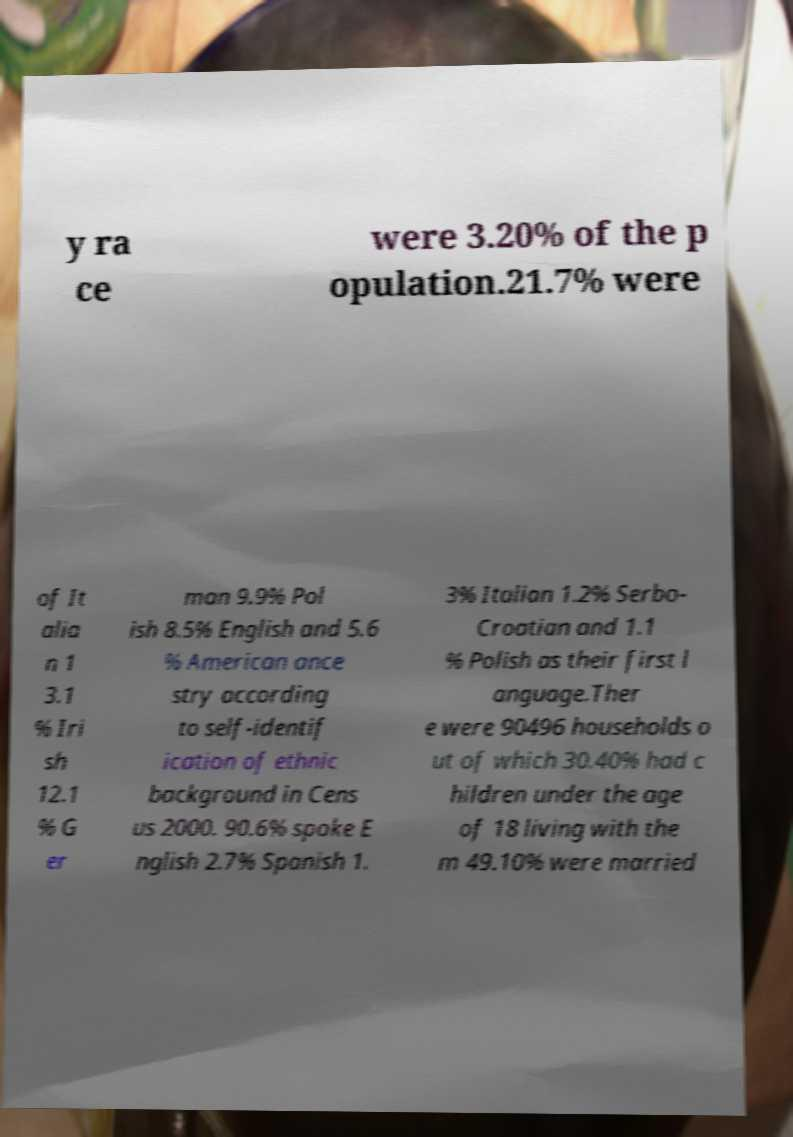Please read and relay the text visible in this image. What does it say? y ra ce were 3.20% of the p opulation.21.7% were of It alia n 1 3.1 % Iri sh 12.1 % G er man 9.9% Pol ish 8.5% English and 5.6 % American ance stry according to self-identif ication of ethnic background in Cens us 2000. 90.6% spoke E nglish 2.7% Spanish 1. 3% Italian 1.2% Serbo- Croatian and 1.1 % Polish as their first l anguage.Ther e were 90496 households o ut of which 30.40% had c hildren under the age of 18 living with the m 49.10% were married 